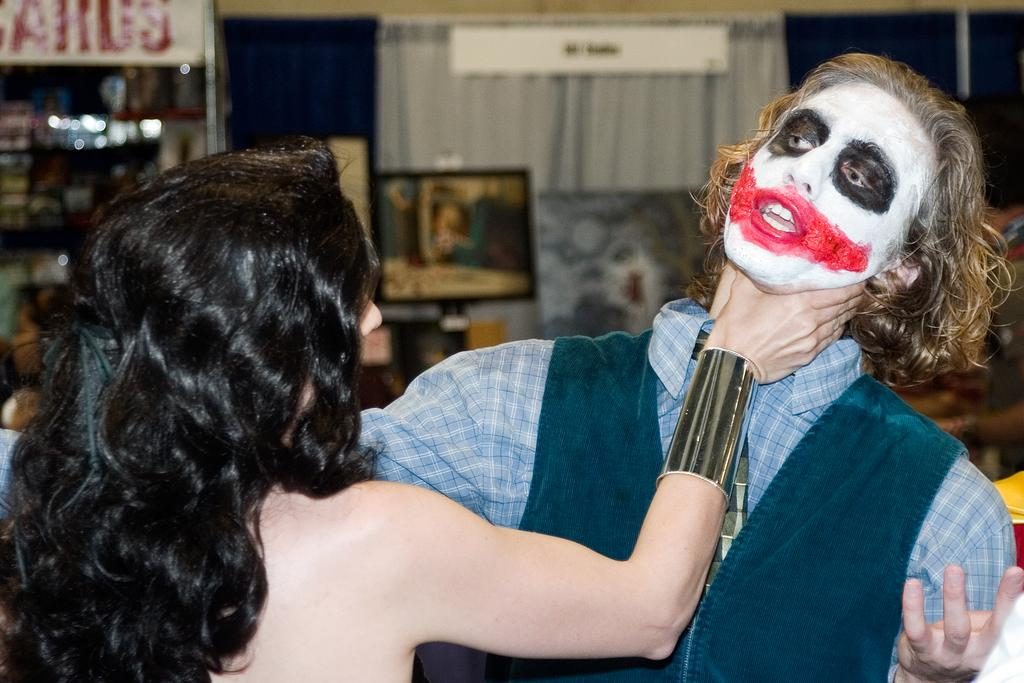How many people are present in the image? There are two people, a man and a woman, present in the image. What can be seen on the backside of the image? There is a television on the backside of the image. What is written or displayed on the board in the image? There is a board with text on it in the image. What type of window treatment is present in the image? There are curtains in the image. What type of structure is visible in the image? There is a wall in the image. Can you see any whips or jellyfish in the image? No, there are no whips or jellyfish present in the image. 